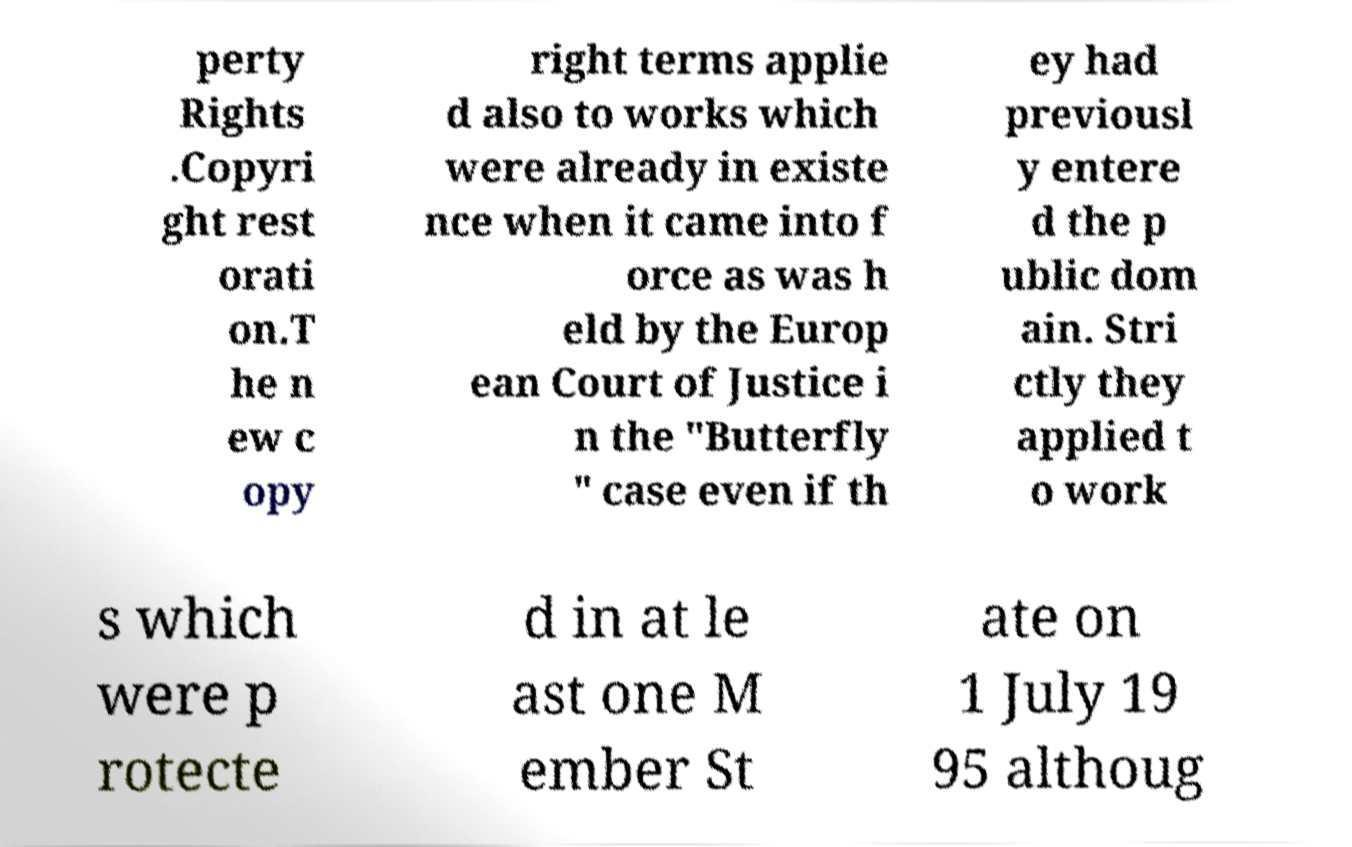Please read and relay the text visible in this image. What does it say? perty Rights .Copyri ght rest orati on.T he n ew c opy right terms applie d also to works which were already in existe nce when it came into f orce as was h eld by the Europ ean Court of Justice i n the "Butterfly " case even if th ey had previousl y entere d the p ublic dom ain. Stri ctly they applied t o work s which were p rotecte d in at le ast one M ember St ate on 1 July 19 95 althoug 